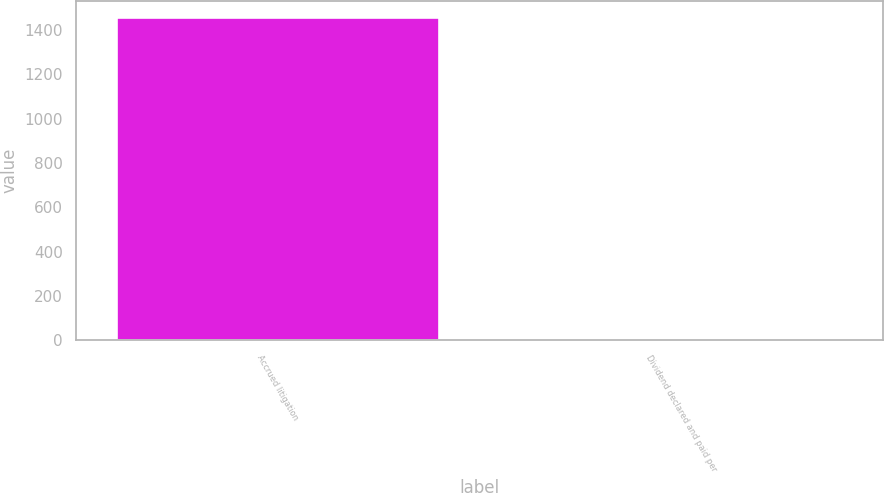<chart> <loc_0><loc_0><loc_500><loc_500><bar_chart><fcel>Accrued litigation<fcel>Dividend declared and paid per<nl><fcel>1456<fcel>0.4<nl></chart> 